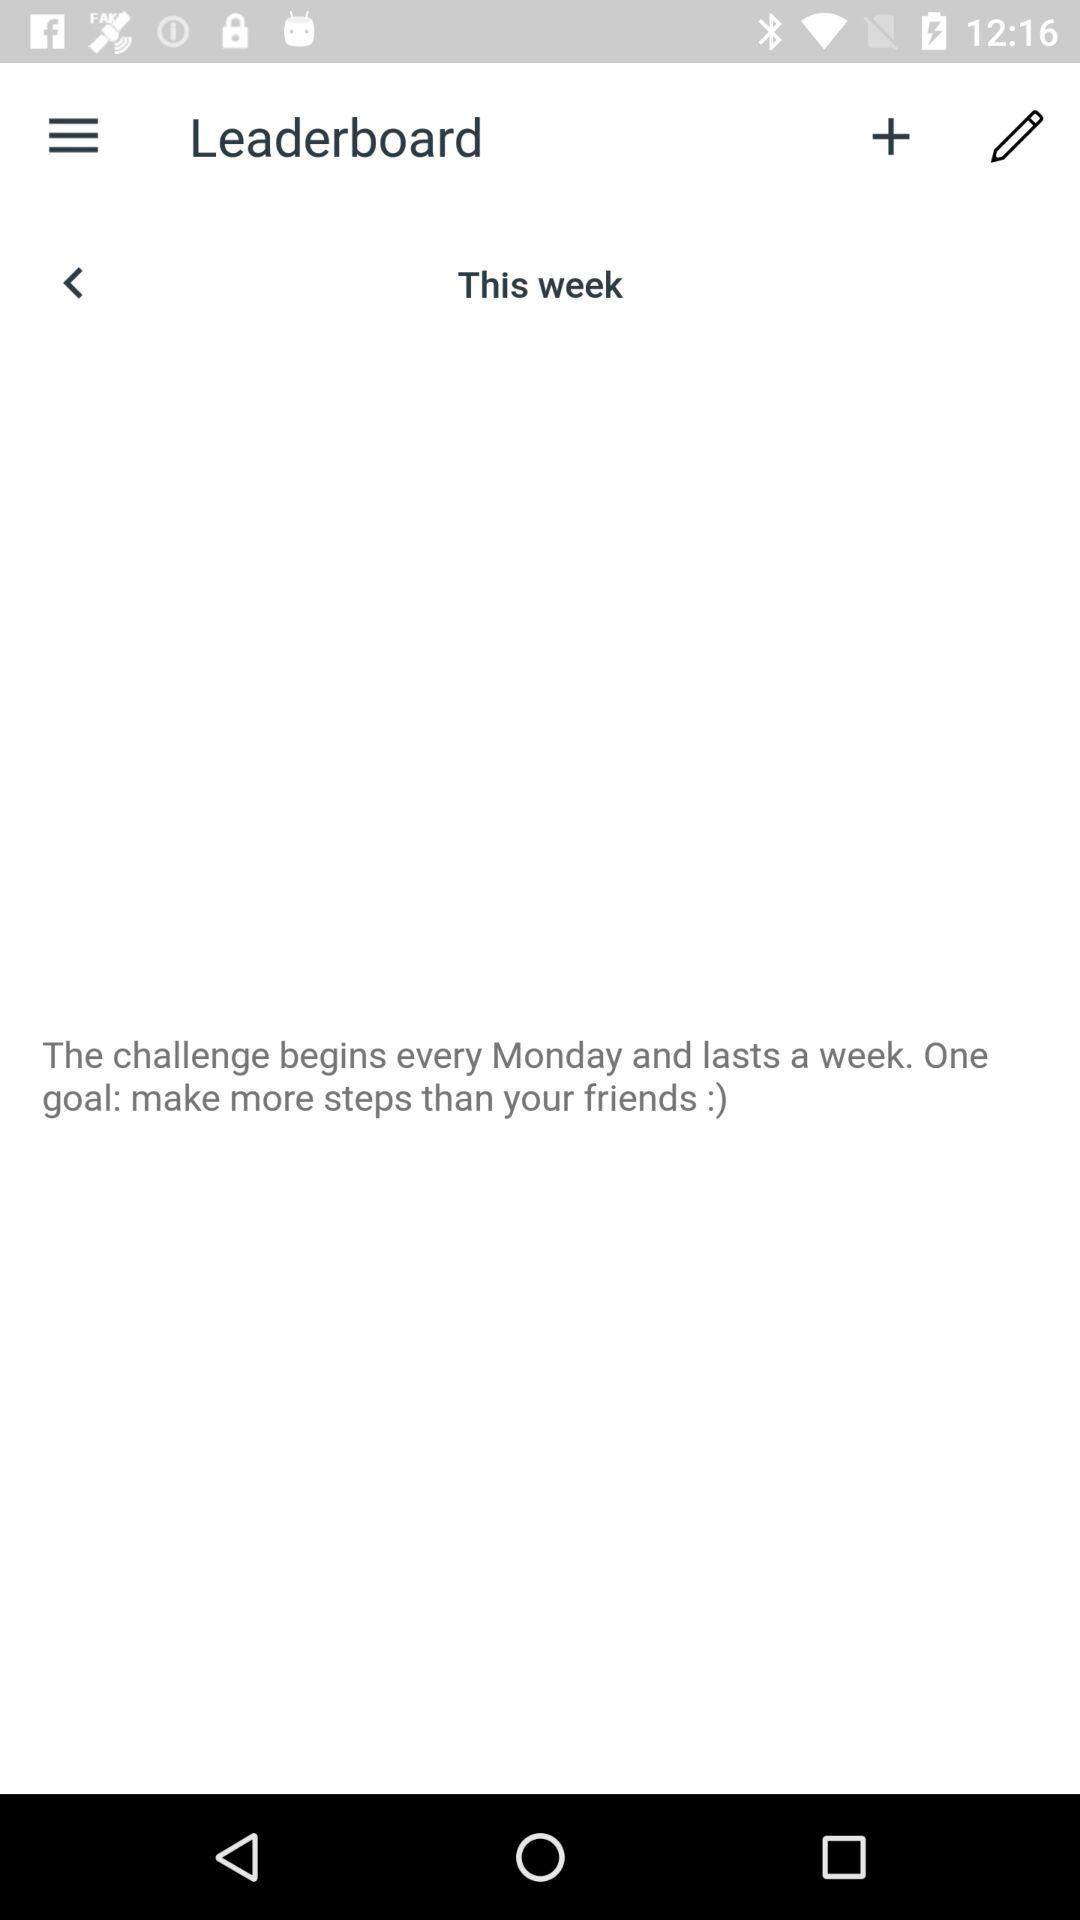On which day does the challenge begin? The challenge begins every Monday. 